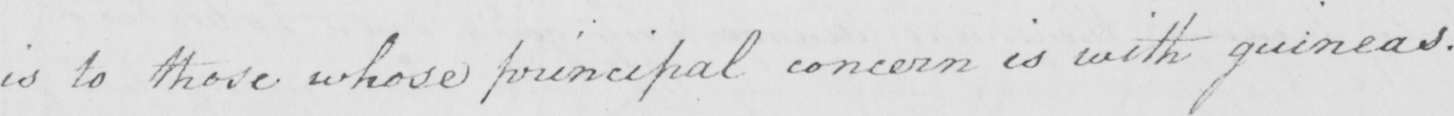What is written in this line of handwriting? is to those whose principal concern is with guineas . 